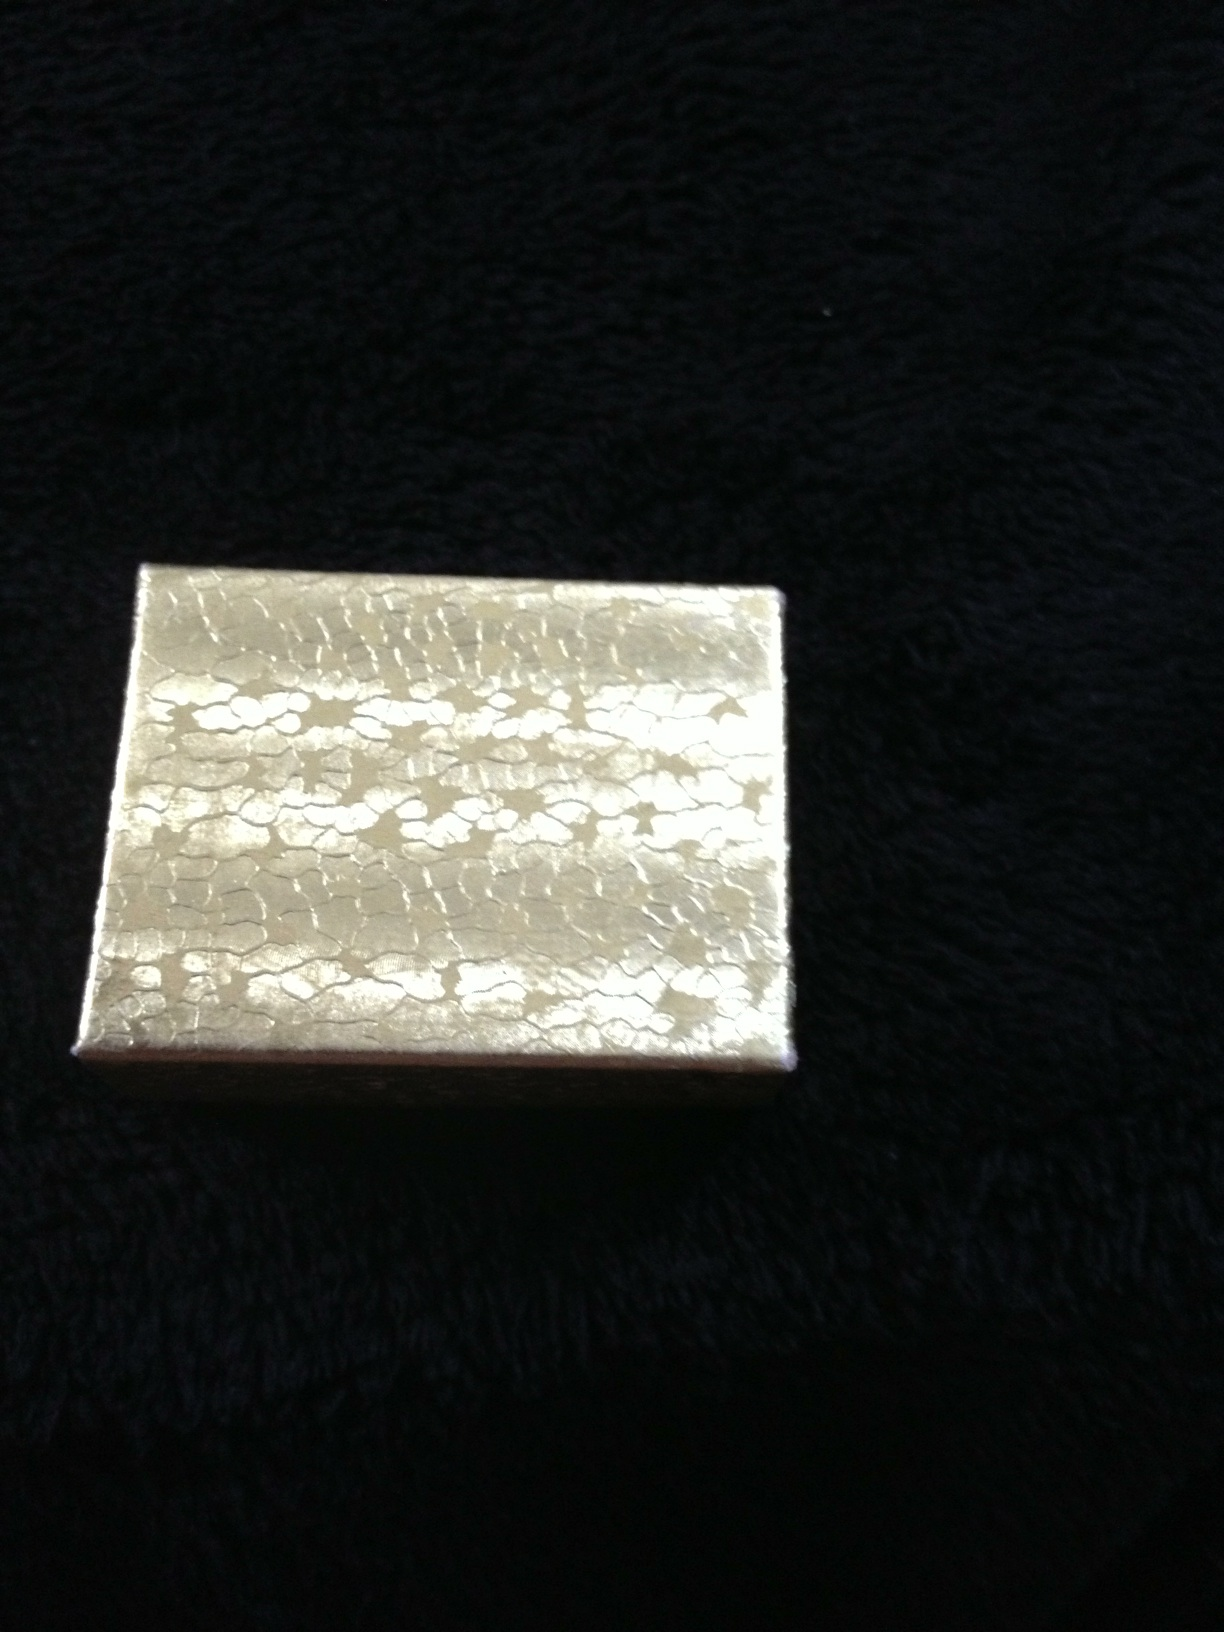Can you imagine a historical scenario for this box? In a historical context, this elegant box might have belonged to a noblewoman during the Renaissance period. It could have been part of her collection of fine objects, used to store valuable jewelry or sentimental tokens. The craftsmanship suggests it was made by a skilled artisan, possibly commissioned for a special occasion. What could be a modern, realistic use for this box? In modern times, this box could be utilized as a gift box, providing an elegant presentation for a thoughtful present. It could also serve as a decorative piece on a dresser or vanity, used to store rings, earrings, or other small jewelry pieces. What kind of creative purpose could this box serve? For a creative purpose, imagine this box as a treasure chest used in a whimsical scavenger hunt or mystery game. Participants could search for hidden clues and uncover secrets by discovering this ornate box, adding an element of excitement and intrigue to the activity. 